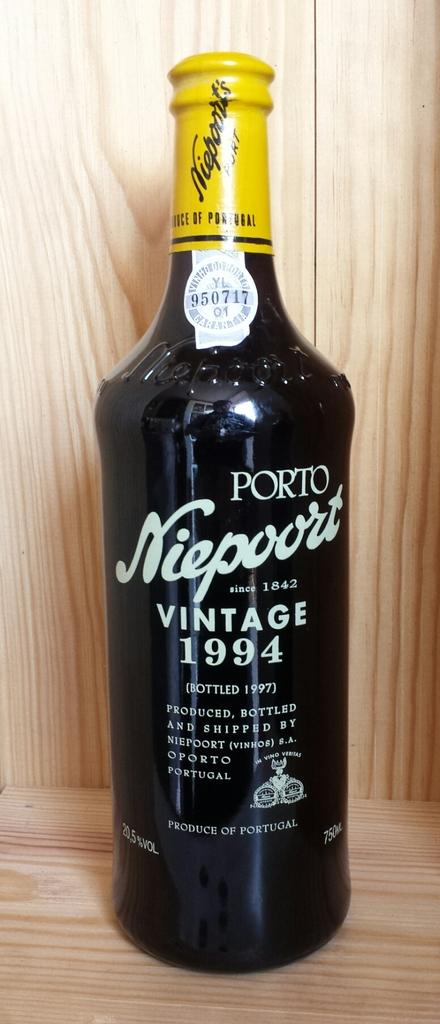<image>
Provide a brief description of the given image. A pottle of Porto Niepoort vintage wine 1994 